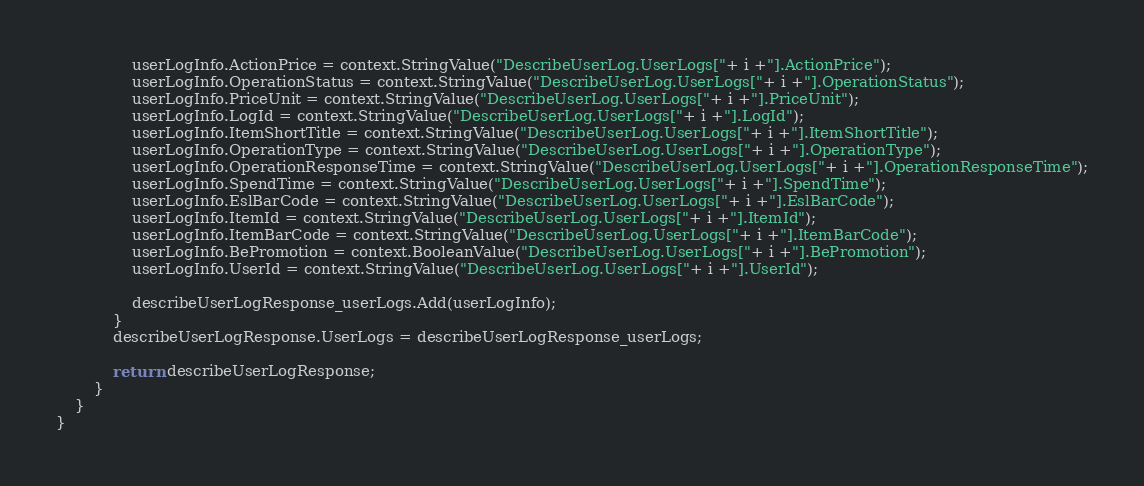<code> <loc_0><loc_0><loc_500><loc_500><_C#_>				userLogInfo.ActionPrice = context.StringValue("DescribeUserLog.UserLogs["+ i +"].ActionPrice");
				userLogInfo.OperationStatus = context.StringValue("DescribeUserLog.UserLogs["+ i +"].OperationStatus");
				userLogInfo.PriceUnit = context.StringValue("DescribeUserLog.UserLogs["+ i +"].PriceUnit");
				userLogInfo.LogId = context.StringValue("DescribeUserLog.UserLogs["+ i +"].LogId");
				userLogInfo.ItemShortTitle = context.StringValue("DescribeUserLog.UserLogs["+ i +"].ItemShortTitle");
				userLogInfo.OperationType = context.StringValue("DescribeUserLog.UserLogs["+ i +"].OperationType");
				userLogInfo.OperationResponseTime = context.StringValue("DescribeUserLog.UserLogs["+ i +"].OperationResponseTime");
				userLogInfo.SpendTime = context.StringValue("DescribeUserLog.UserLogs["+ i +"].SpendTime");
				userLogInfo.EslBarCode = context.StringValue("DescribeUserLog.UserLogs["+ i +"].EslBarCode");
				userLogInfo.ItemId = context.StringValue("DescribeUserLog.UserLogs["+ i +"].ItemId");
				userLogInfo.ItemBarCode = context.StringValue("DescribeUserLog.UserLogs["+ i +"].ItemBarCode");
				userLogInfo.BePromotion = context.BooleanValue("DescribeUserLog.UserLogs["+ i +"].BePromotion");
				userLogInfo.UserId = context.StringValue("DescribeUserLog.UserLogs["+ i +"].UserId");

				describeUserLogResponse_userLogs.Add(userLogInfo);
			}
			describeUserLogResponse.UserLogs = describeUserLogResponse_userLogs;
        
			return describeUserLogResponse;
        }
    }
}
</code> 